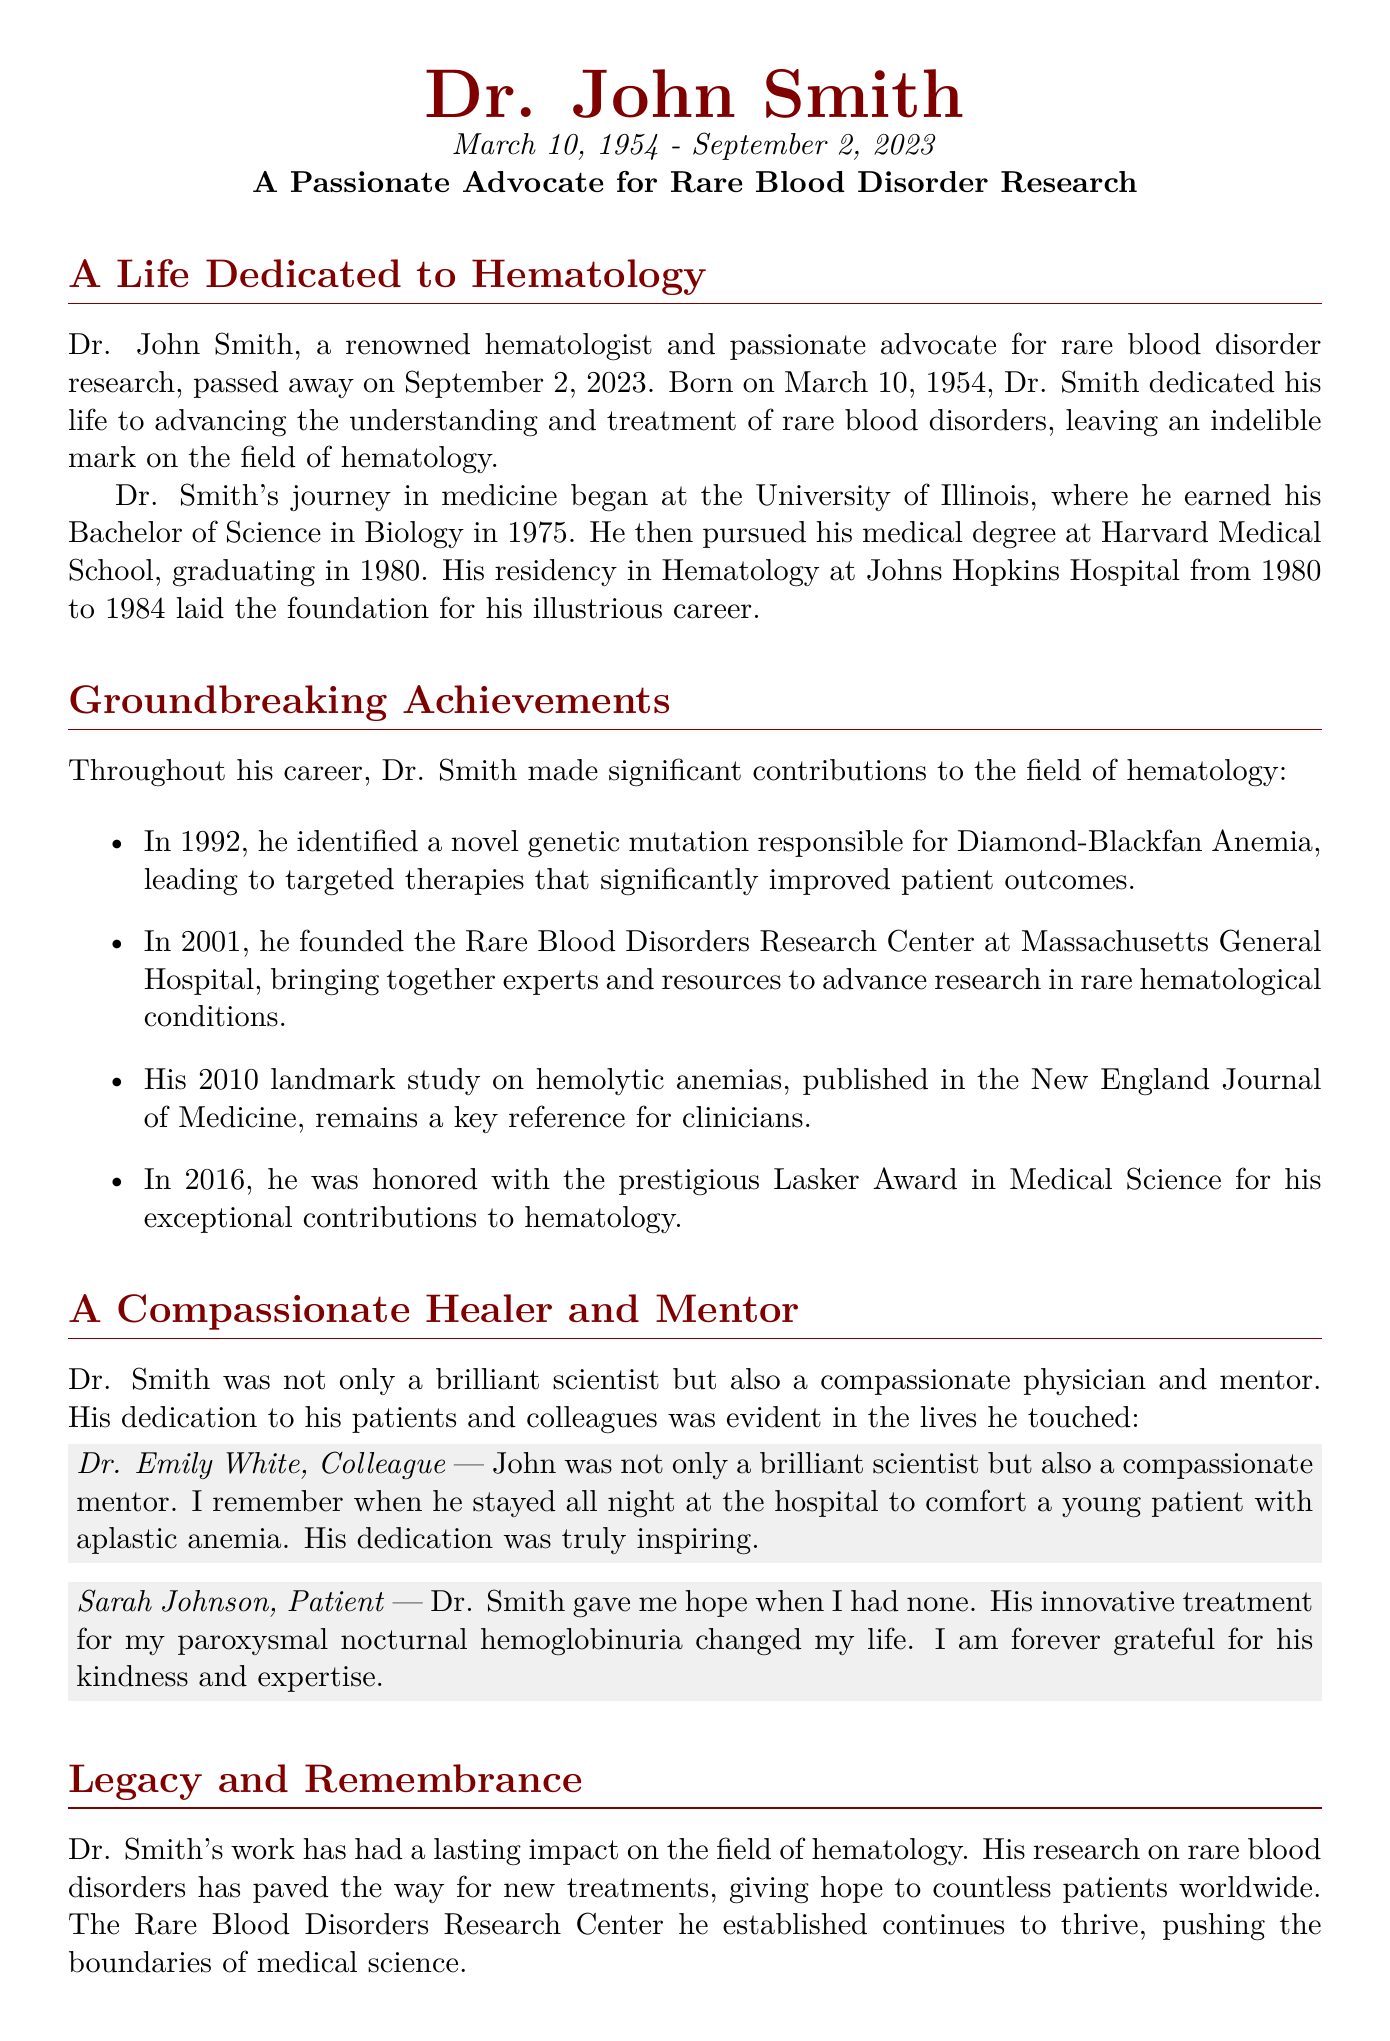What is Dr. John Smith's date of birth? The document states that Dr. John Smith was born on March 10, 1954.
Answer: March 10, 1954 What award did Dr. Smith receive in 2016? The obituary notes that Dr. Smith was honored with the prestigious Lasker Award in Medical Science in 2016.
Answer: Lasker Award in Medical Science What significant contribution did Dr. Smith make in 1992? In 1992, Dr. Smith identified a novel genetic mutation responsible for Diamond-Blackfan Anemia.
Answer: Genetic mutation for Diamond-Blackfan Anemia Where did Dr. Smith establish the Rare Blood Disorders Research Center? The document mentions that he founded the Rare Blood Disorders Research Center at Massachusetts General Hospital.
Answer: Massachusetts General Hospital Who described Dr. Smith as a compassionate mentor? Dr. Emily White, a colleague, mentioned Dr. Smith's compassion and mentorship.
Answer: Dr. Emily White What impact did Dr. Smith's research have on patients? His work on rare blood disorders paved the way for new treatments, giving hope to countless patients.
Answer: New treatments and hope How many children did Dr. Smith have? The obituary states that Dr. Smith is survived by his children, Alice and Michael, indicating he had two children.
Answer: Two children What is a key reference for clinicians mentioned in the document? The landmark study published in the New England Journal of Medicine in 2010 is described as a key reference for clinicians.
Answer: Landmark study on hemolytic anemias What are the names of Dr. Smith's family members mentioned? The document lists his wife, Jane Smith, and their children, Alice and Michael, as surviving family members.
Answer: Jane, Alice, and Michael 